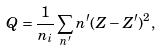<formula> <loc_0><loc_0><loc_500><loc_500>Q = \frac { 1 } { n _ { i } } \sum _ { n ^ { \prime } } n ^ { \prime } ( Z - Z ^ { \prime } ) ^ { 2 } ,</formula> 